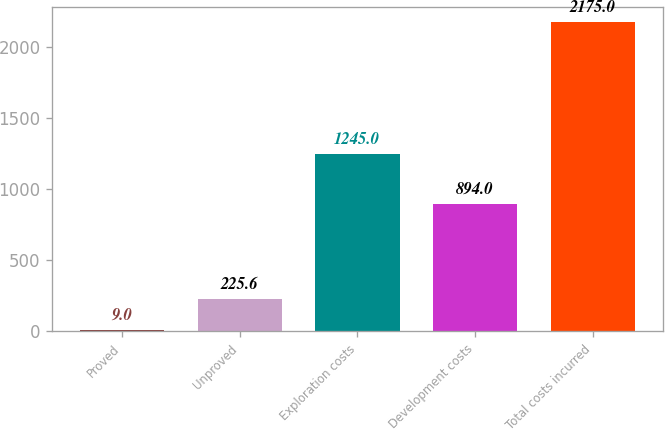Convert chart to OTSL. <chart><loc_0><loc_0><loc_500><loc_500><bar_chart><fcel>Proved<fcel>Unproved<fcel>Exploration costs<fcel>Development costs<fcel>Total costs incurred<nl><fcel>9<fcel>225.6<fcel>1245<fcel>894<fcel>2175<nl></chart> 